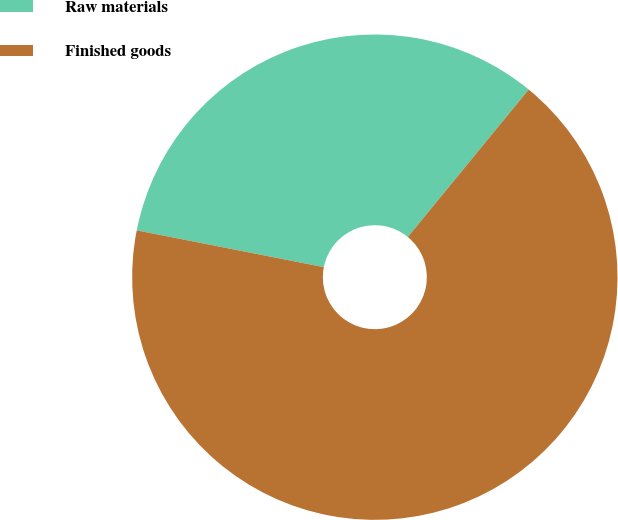Convert chart to OTSL. <chart><loc_0><loc_0><loc_500><loc_500><pie_chart><fcel>Raw materials<fcel>Finished goods<nl><fcel>32.84%<fcel>67.16%<nl></chart> 